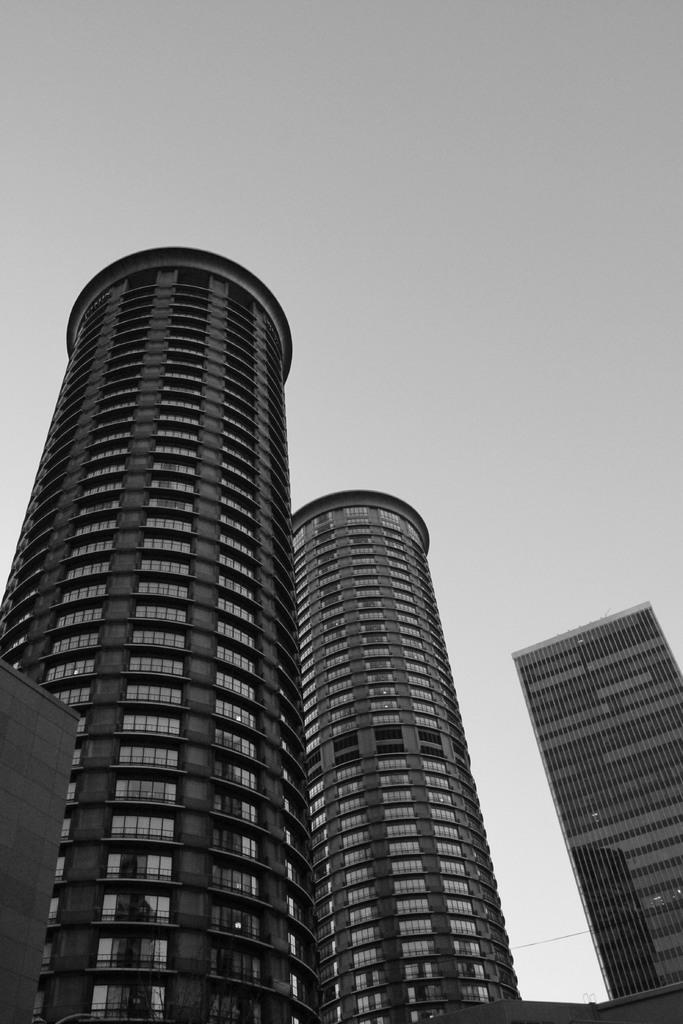What structures are present in the image? There are buildings in the image. What can be seen in the background of the image? The sky is visible in the background of the image. What type of book is being read by the apple in the image? There is no book or apple present in the image; it only features buildings and the sky. 